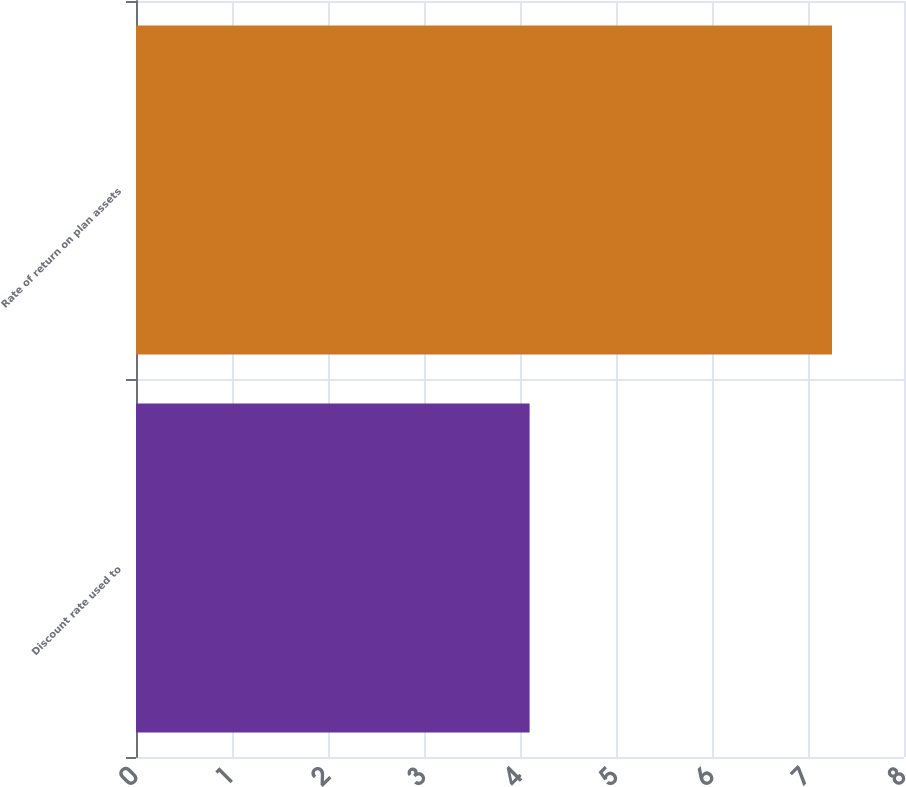Convert chart. <chart><loc_0><loc_0><loc_500><loc_500><bar_chart><fcel>Discount rate used to<fcel>Rate of return on plan assets<nl><fcel>4.1<fcel>7.25<nl></chart> 